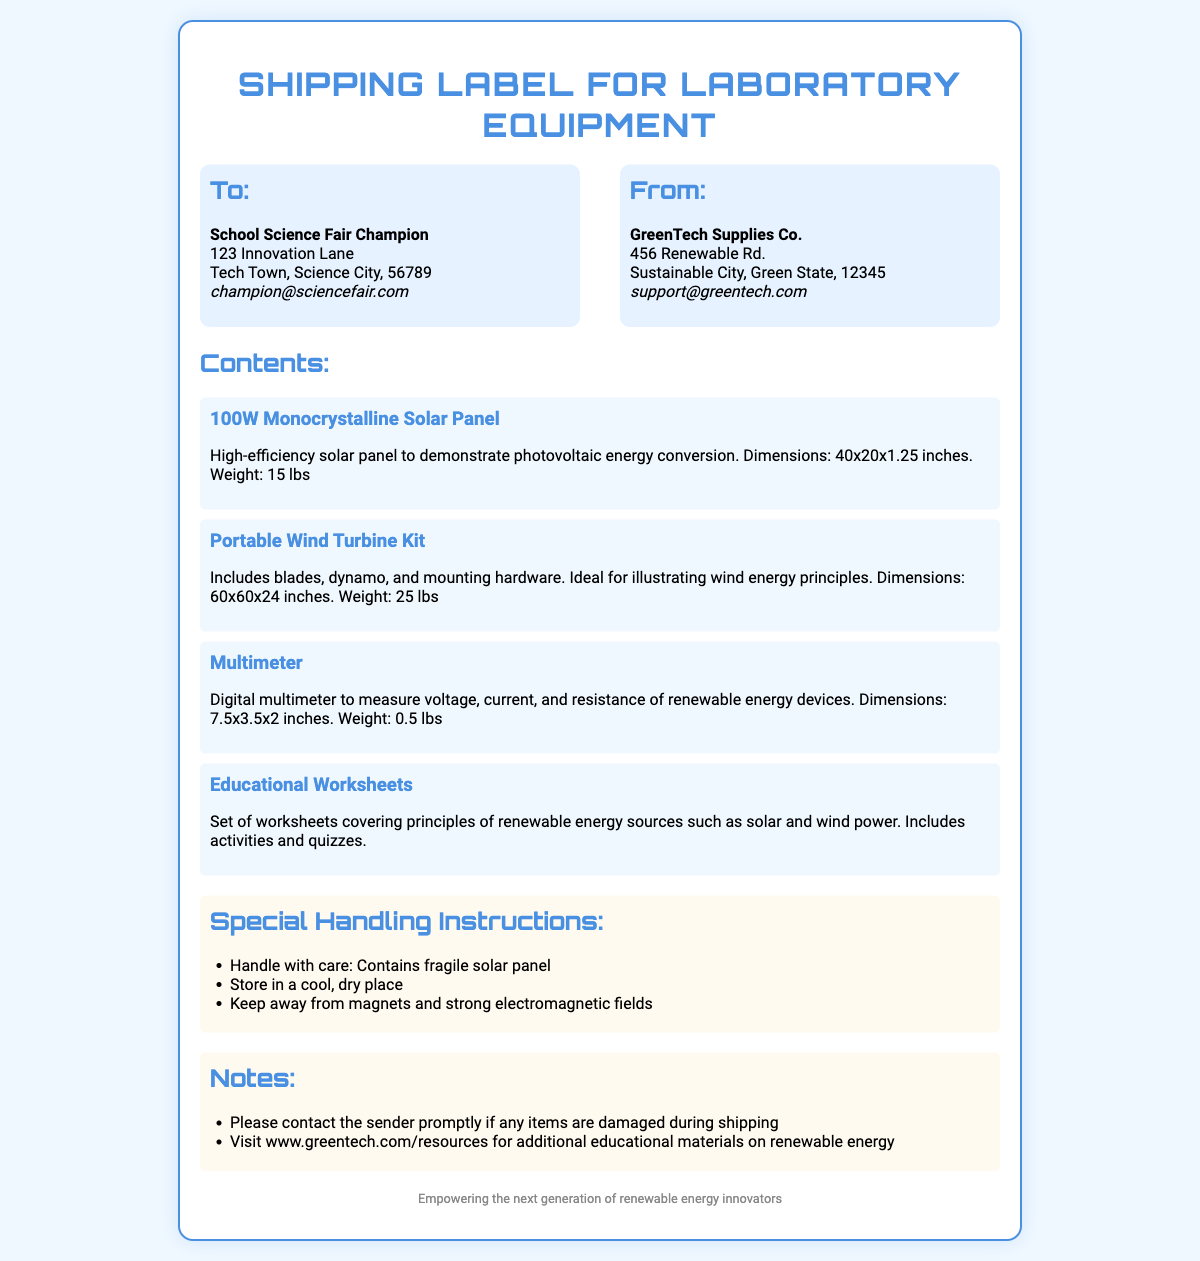what is the name of the recipient? The recipient's name is listed in the 'To:' section of the document.
Answer: School Science Fair Champion what company is the sender? The sender's company name is found in the 'From:' section of the document.
Answer: GreenTech Supplies Co how many items are listed in the contents? The document lists each item under the 'Contents:' section, and these count towards the total.
Answer: 4 what is the weight of the Portable Wind Turbine Kit? The weight is specified in the description of the item in the 'Contents:' section.
Answer: 25 lbs what special handling instruction is given for the solar panel? This information is found under the 'Special Handling Instructions:' section.
Answer: Handle with care: Contains fragile solar panel what is the dimension of the 100W Monocrystalline Solar Panel? The dimensions are provided in the description of the item under 'Contents:'.
Answer: 40x20x1.25 inches what kind of worksheets are included? The description of the worksheets is mentioned in the 'Contents:' section of the document.
Answer: Educational Worksheets what should you do if items are damaged during shipping? This is a specific instruction found under the 'Notes:' section.
Answer: Please contact the sender promptly if any items are damaged during shipping 